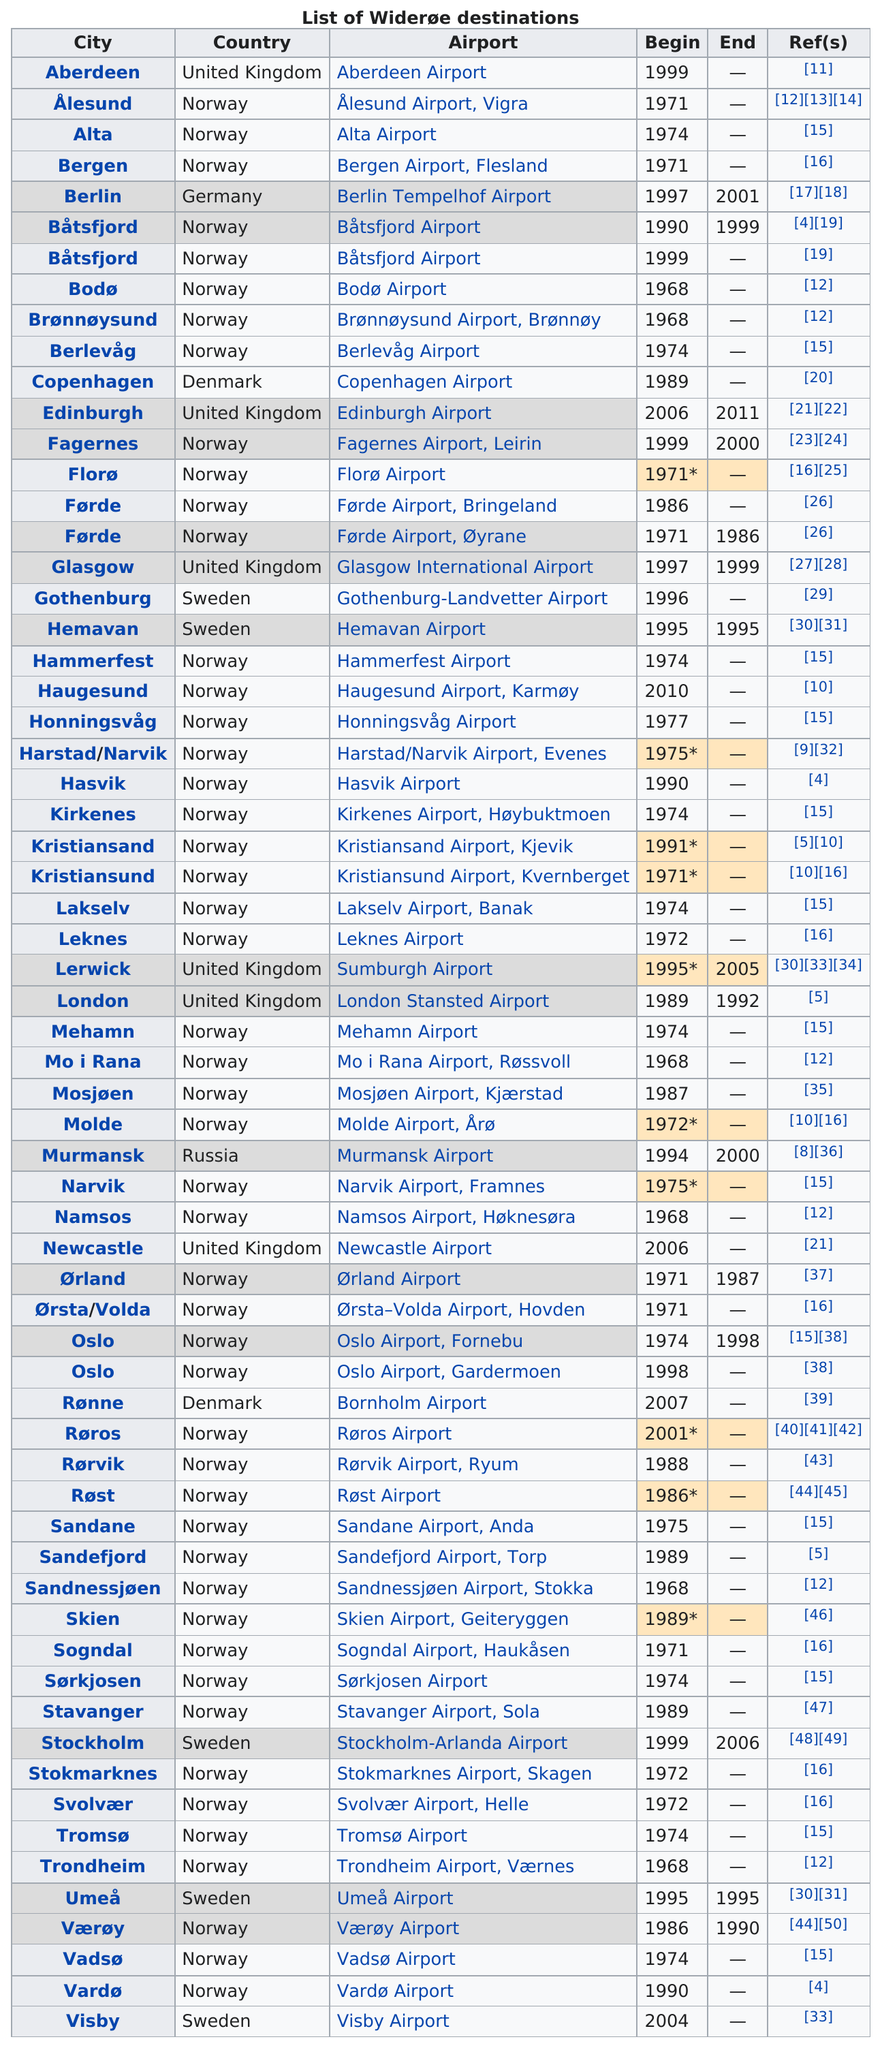Indicate a few pertinent items in this graphic. After the year 2010, a total of 50 destinations remained available. Name a country listed other than Norway? The United Kingdom. In 1999, there were a total of 4 Winderoe destinations. Edinburgh, United Kingdom, became available in the same year as Newcastle, which is a destination city. According to available records, Hemavan, Sweden had a maximum of one winderoe destination for a number of years. 